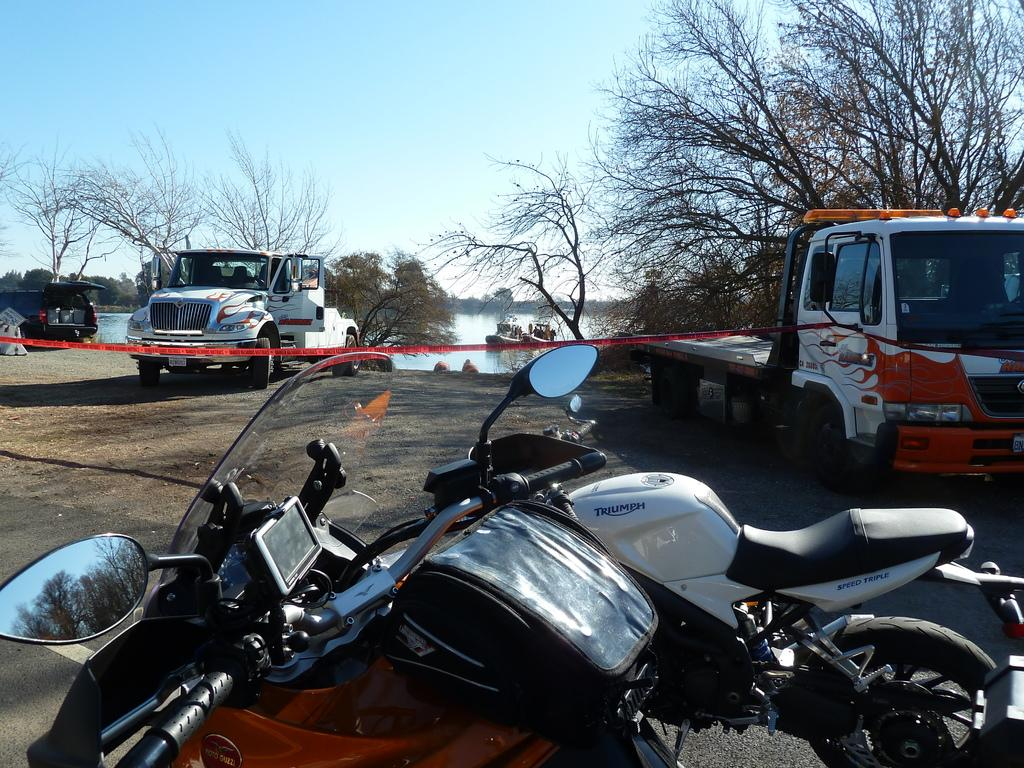What types of vehicles are in the image? There are motorcycles and trucks in the image. What natural feature can be seen in the image? There is a pond in the image. What type of vegetation is near the pond? Trees are present near the pond. What is visible in the background of the image? The sky is visible in the image. What type of hammer can be seen in the image? There is no hammer present in the image. Can you hear the thunder in the image? There is no sound in the image, so it is not possible to hear thunder. 